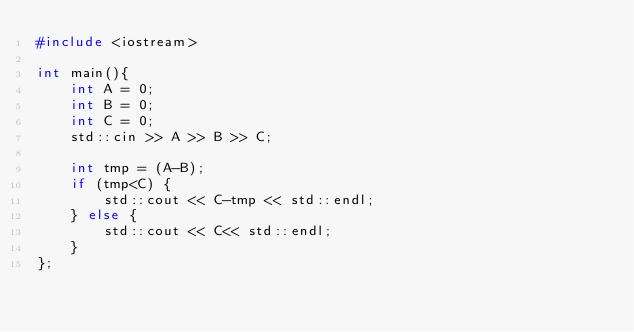Convert code to text. <code><loc_0><loc_0><loc_500><loc_500><_C++_>#include <iostream>

int main(){
    int A = 0;
    int B = 0;
    int C = 0;
    std::cin >> A >> B >> C;

    int tmp = (A-B);
    if (tmp<C) {
        std::cout << C-tmp << std::endl;
    } else {
        std::cout << C<< std::endl;
    }
};</code> 